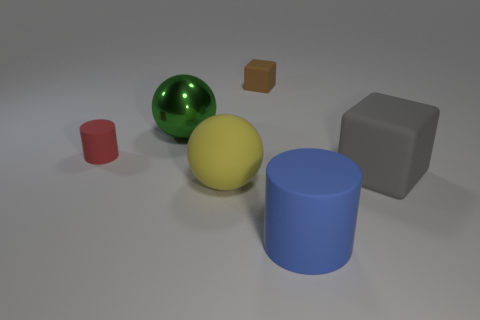Does the brown matte thing have the same size as the gray rubber thing?
Offer a terse response. No. There is a blue thing that is the same material as the tiny red thing; what shape is it?
Keep it short and to the point. Cylinder. There is a tiny rubber thing on the right side of the metallic thing; is its shape the same as the large blue thing?
Offer a very short reply. No. There is a cylinder to the right of the matte cylinder that is left of the blue cylinder; what size is it?
Give a very brief answer. Large. There is a small cube that is made of the same material as the small red thing; what is its color?
Your answer should be compact. Brown. How many gray things are the same size as the brown rubber block?
Offer a very short reply. 0. How many green things are either cylinders or big matte blocks?
Your answer should be compact. 0. What number of objects are either purple metallic spheres or small red matte objects that are in front of the tiny block?
Give a very brief answer. 1. What is the material of the block that is behind the small red matte cylinder?
Your answer should be compact. Rubber. What shape is the gray rubber thing that is the same size as the blue matte object?
Ensure brevity in your answer.  Cube. 